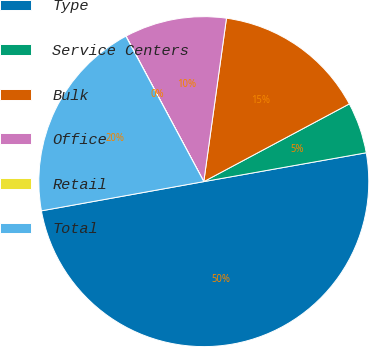Convert chart. <chart><loc_0><loc_0><loc_500><loc_500><pie_chart><fcel>Type<fcel>Service Centers<fcel>Bulk<fcel>Office<fcel>Retail<fcel>Total<nl><fcel>49.97%<fcel>5.01%<fcel>15.0%<fcel>10.01%<fcel>0.02%<fcel>20.0%<nl></chart> 